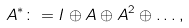Convert formula to latex. <formula><loc_0><loc_0><loc_500><loc_500>A ^ { * } \colon = I \oplus A \oplus A ^ { 2 } \oplus \dots ,</formula> 